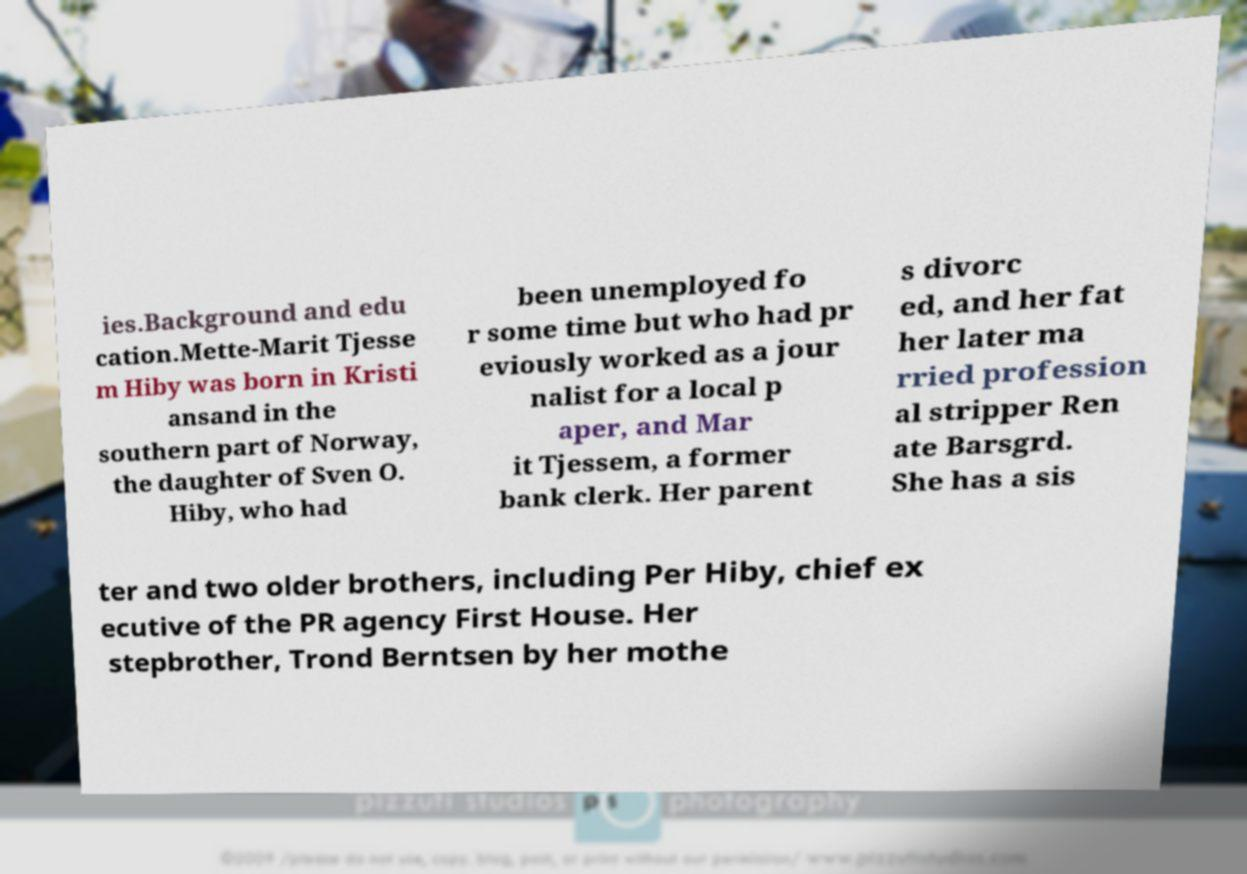There's text embedded in this image that I need extracted. Can you transcribe it verbatim? ies.Background and edu cation.Mette-Marit Tjesse m Hiby was born in Kristi ansand in the southern part of Norway, the daughter of Sven O. Hiby, who had been unemployed fo r some time but who had pr eviously worked as a jour nalist for a local p aper, and Mar it Tjessem, a former bank clerk. Her parent s divorc ed, and her fat her later ma rried profession al stripper Ren ate Barsgrd. She has a sis ter and two older brothers, including Per Hiby, chief ex ecutive of the PR agency First House. Her stepbrother, Trond Berntsen by her mothe 